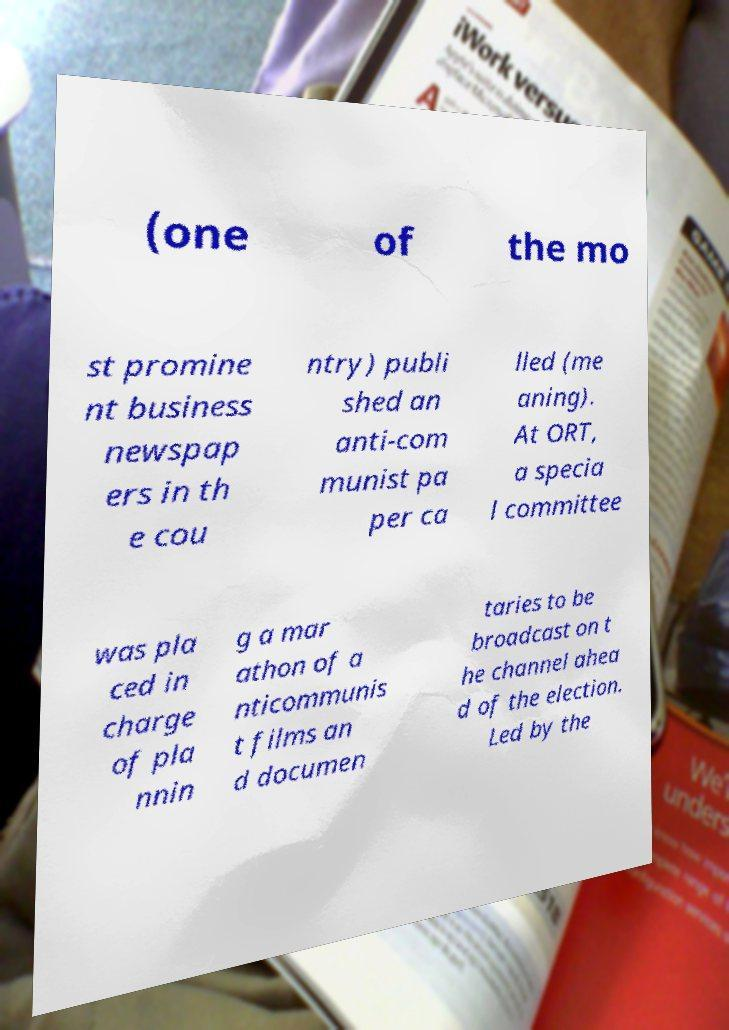What messages or text are displayed in this image? I need them in a readable, typed format. (one of the mo st promine nt business newspap ers in th e cou ntry) publi shed an anti-com munist pa per ca lled (me aning). At ORT, a specia l committee was pla ced in charge of pla nnin g a mar athon of a nticommunis t films an d documen taries to be broadcast on t he channel ahea d of the election. Led by the 